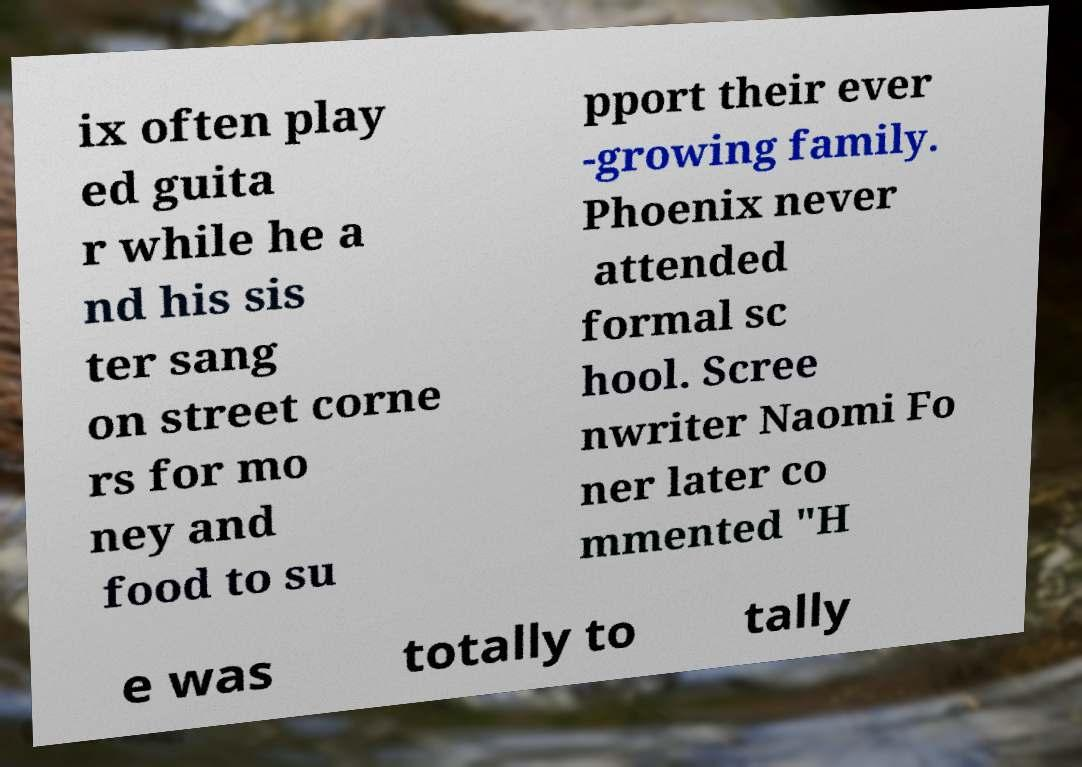What messages or text are displayed in this image? I need them in a readable, typed format. ix often play ed guita r while he a nd his sis ter sang on street corne rs for mo ney and food to su pport their ever -growing family. Phoenix never attended formal sc hool. Scree nwriter Naomi Fo ner later co mmented "H e was totally to tally 